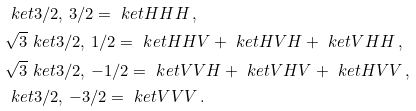Convert formula to latex. <formula><loc_0><loc_0><loc_500><loc_500>& \ k e t { 3 / 2 , \, 3 / 2 } = \ k e t { H H H } \, , \\ & \sqrt { 3 } \ k e t { 3 / 2 , \, 1 / 2 } = \ k e t { H H V } + \ k e t { H V H } + \ k e t { V H H } \, , \\ & \sqrt { 3 } \ k e t { 3 / 2 , \, - 1 / 2 } = \ k e t { V V H } + \ k e t { V H V } + \ k e t { H V V } \, , \\ & \ k e t { 3 / 2 , \, - 3 / 2 } = \ k e t { V V V } \, .</formula> 